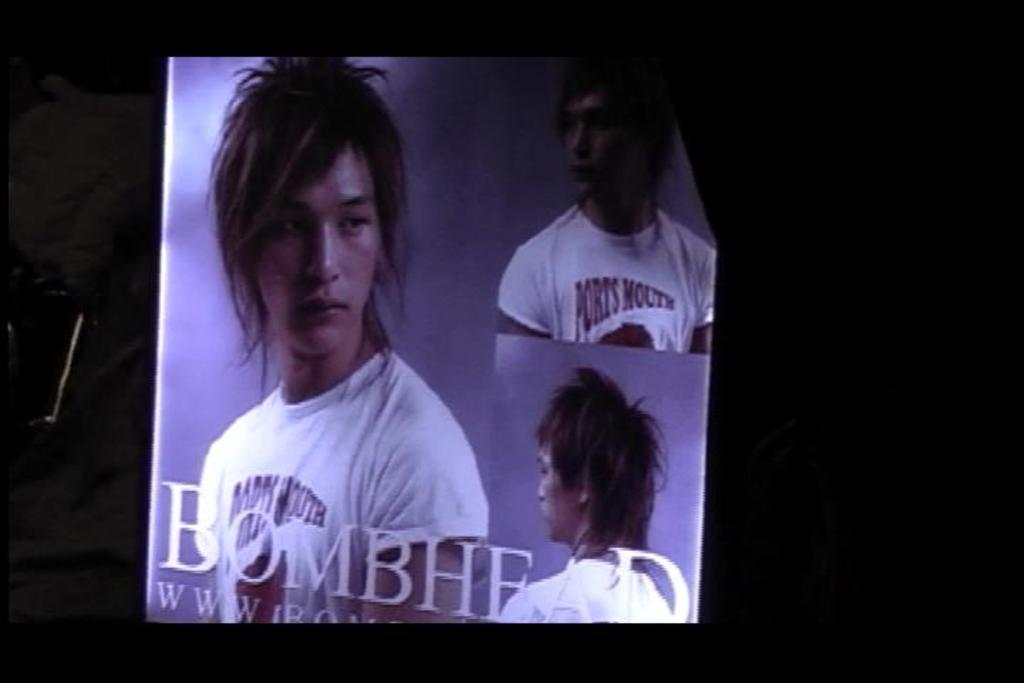Can you describe this image briefly? In this picture, we see a poster or a banner containing the photos of a man who is wearing the white T-shirt. At the bottom, we see some text written. In the background, it is black in color. This picture might be clicked in the dark. 